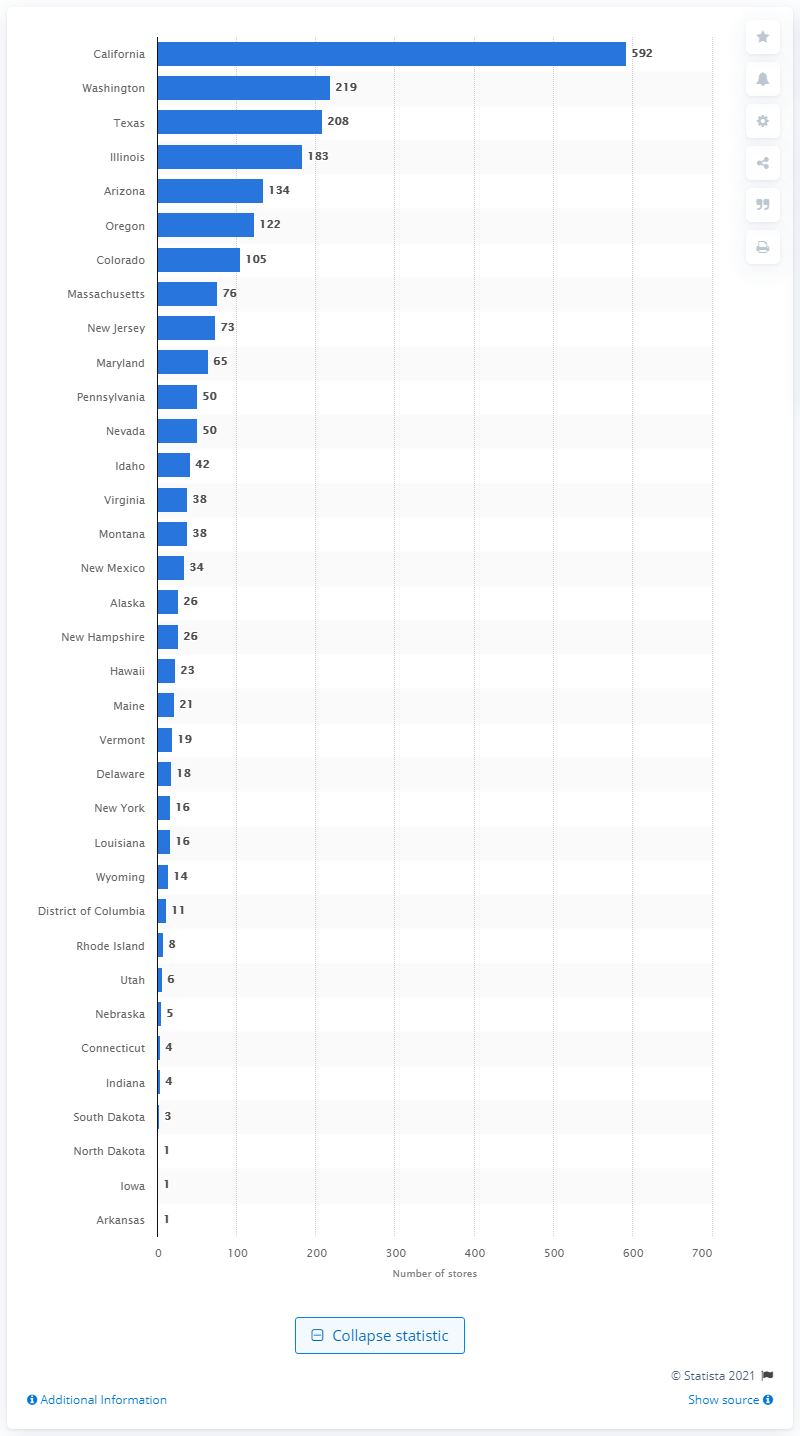Identify some key points in this picture. As of February 29, 2020, Albertsons Companies operated a total of 592 stores in the state of California. As of February 29, 2020, there were 219 Albertsons Companies stores located in the state of Washington. 